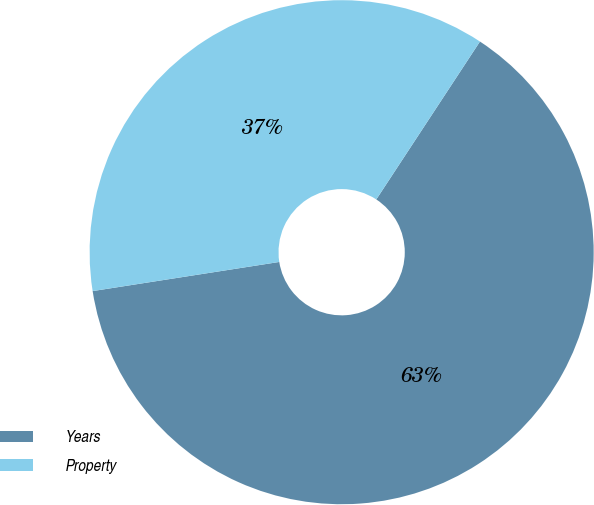Convert chart. <chart><loc_0><loc_0><loc_500><loc_500><pie_chart><fcel>Years<fcel>Property<nl><fcel>63.29%<fcel>36.71%<nl></chart> 